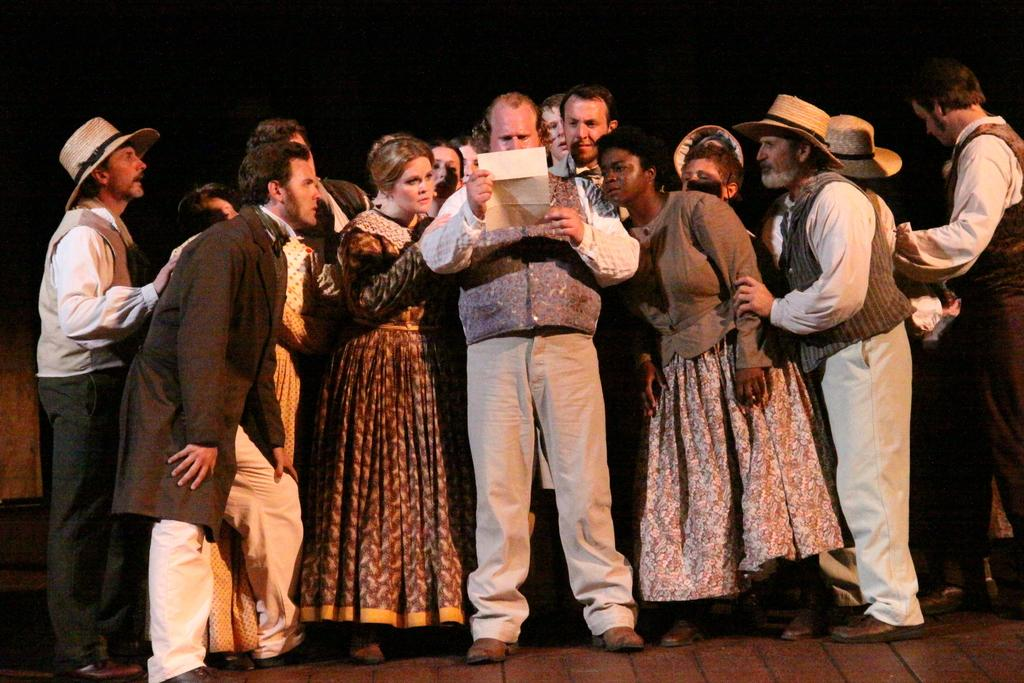What is happening in the image? There are people standing in the image. Can you describe the person at the center? The person at the center is holding a paper in his hand. Are there any accessories or clothing items that stand out in the image? Some people are wearing hats. How many frogs can be seen hopping around in the image? There are no frogs present in the image. What type of mint is being used as a garnish on the person's hat? There is no mint or garnish present on any of the hats in the image. 